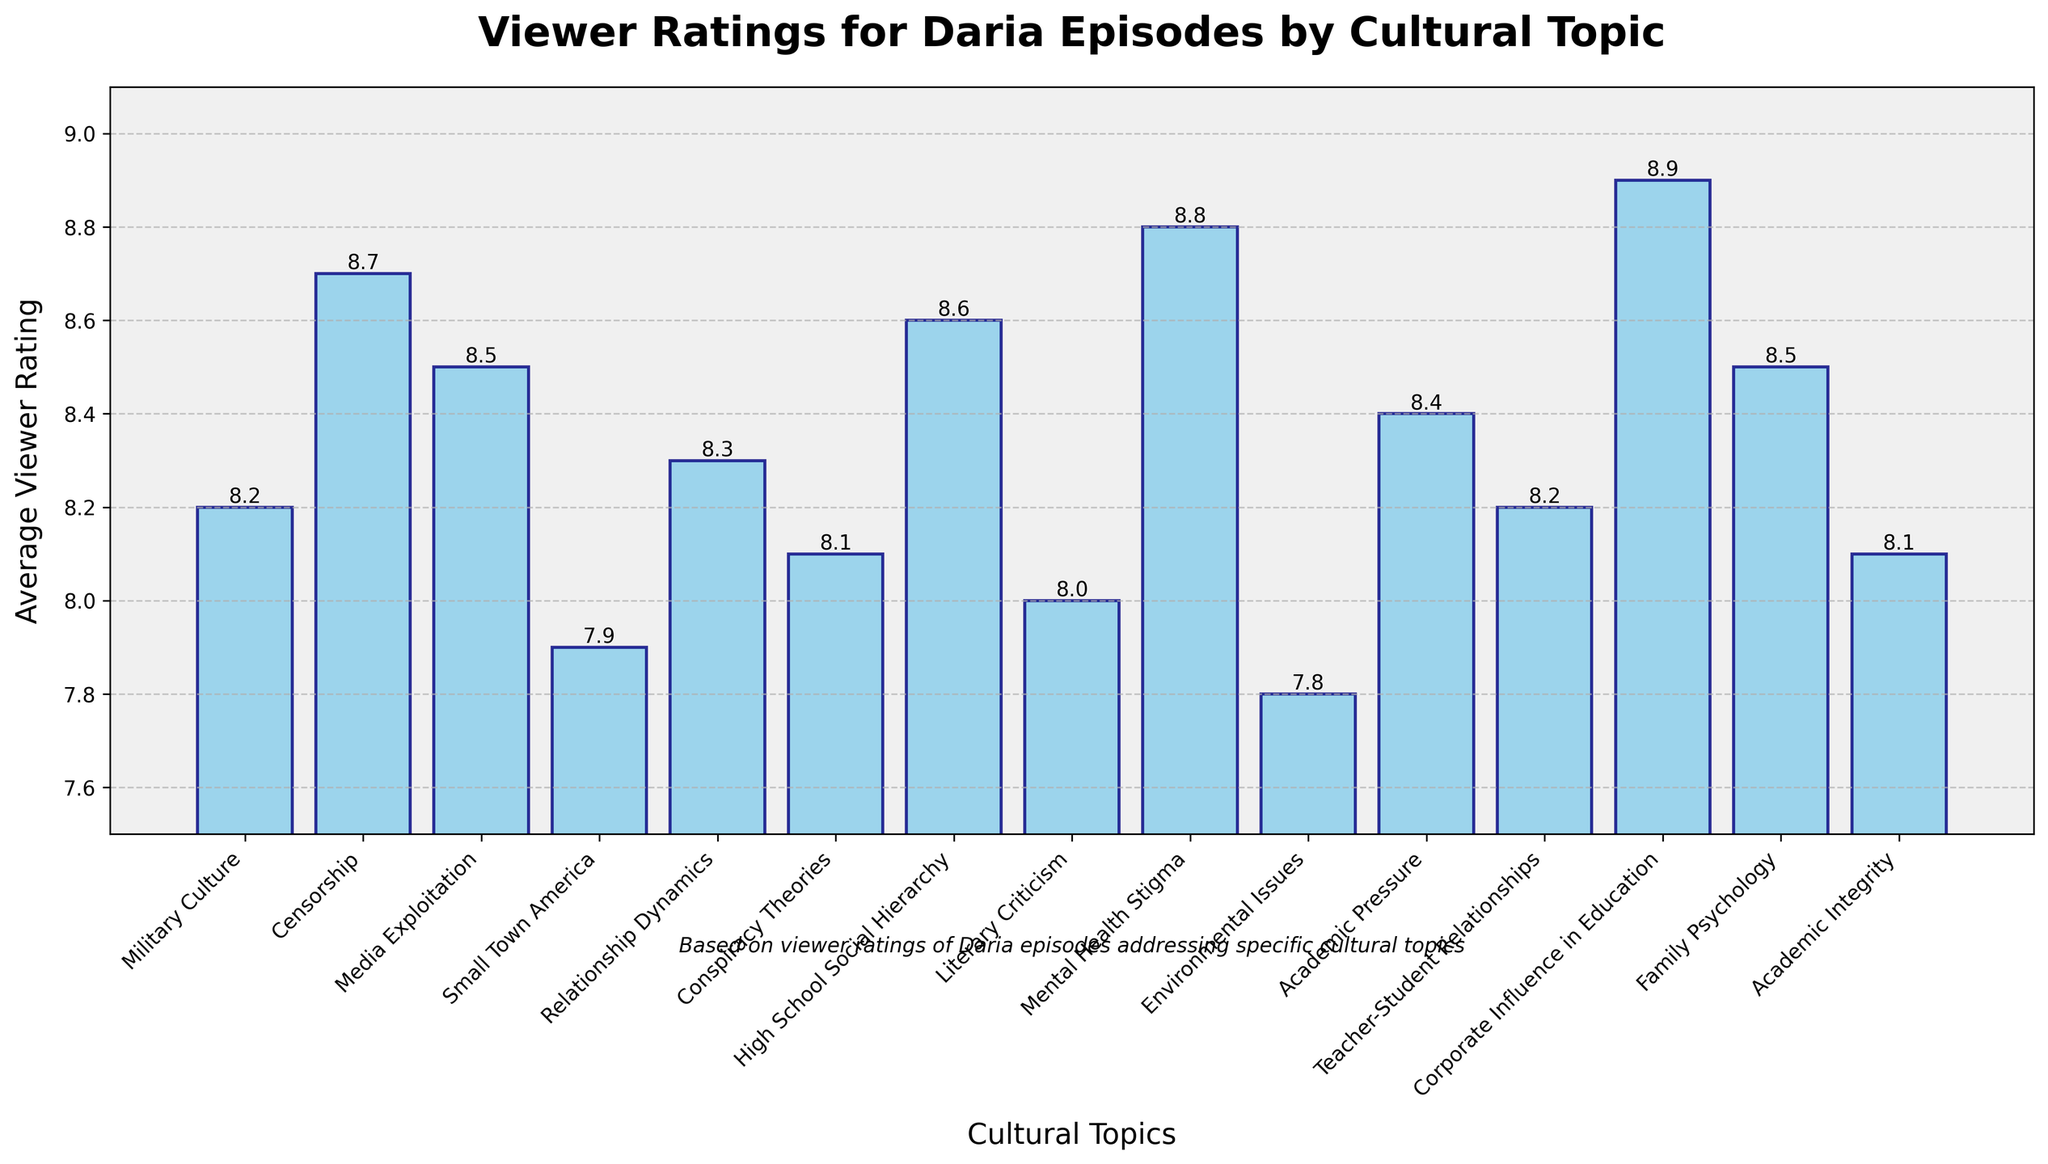Which episode has the highest average viewer rating? First, visually scan the height of each bar and identify the tallest one. The bar for "Fizz Ed" appears to be the highest. Its label and rating confirm it.
Answer: "Fizz Ed" Which episode addresses the topic of censorship, and what is its viewer rating? Look for the bar labeled with the topic "Censorship". "Arts 'N Crass" has a topic of censorship and its rating is listed as 8.7.
Answer: "Arts 'N Crass", 8.7 What is the difference in viewer ratings between the episodes "The Misery Chick" and "Antisocial Climbers"? Identify the bars for "The Misery Chick" and "Antisocial Climbers", read their ratings (8.8 and 7.8 respectively), and calculate the difference: 8.8 - 7.8 = 1.0.
Answer: 1.0 Which episodes have a viewer rating higher than 8.5? Visually identify the bars that exceed the 8.5 mark on the y-axis. These episodes are "Arts 'N Crass", "The Misery Chick", "Fizz Ed", and "Daria Dance Party".
Answer: "Arts 'N Crass", "The Misery Chick", "Fizz Ed", "Daria Dance Party" What is the average viewer rating of the episodes that discuss educational topics: "Fizz Ed", "The F Word", and "Lucky Strike"? Locate these bars and note their ratings: 8.9, 8.4, and 8.2. Sum these ratings: 8.9 + 8.4 + 8.2 = 25.5. Divide by the number of episodes: 25.5 / 3 = 8.5.
Answer: 8.5 Is the viewer rating of "Jane's Addition" higher or lower than the average rating of all the episodes? First, determine the rating of “Jane's Addition” (8.3), then calculate the average rating of all episodes. Sum all ratings and divide by the number of episodes ((8.2 + 8.7 + 8.5 + 7.9 + 8.3 + 8.1 + 8.6 + 8.0 + 8.8 + 7.8 + 8.4 + 8.2 + 8.9 + 8.5 + 8.1)/15 = 8.3). Since the rating of “Jane's Addition” is equal to this average, it’s neither higher nor lower.
Answer: Equal What is the combined rating of episodes covering "Mental Health Stigma", "Family Psychology", and "Media Exploitation"? Identify the bars and read the ratings for "The Misery Chick" (8.8), "Psycho Therapy" (8.5), and "The Lost Girls" (8.5). Sum these ratings: 8.8 + 8.5 + 8.5 = 25.8.
Answer: 25.8 How many episodes have a rating greater than or equal to 8.0 but less than 8.5? Count the bars within this rating interval. They are "Jane's Addition" (8.3), "Lucky Strike" (8.2), "The Lawndale File" (8.1), and "The Story of D" (8.0), making a total of 4.
Answer: 4 